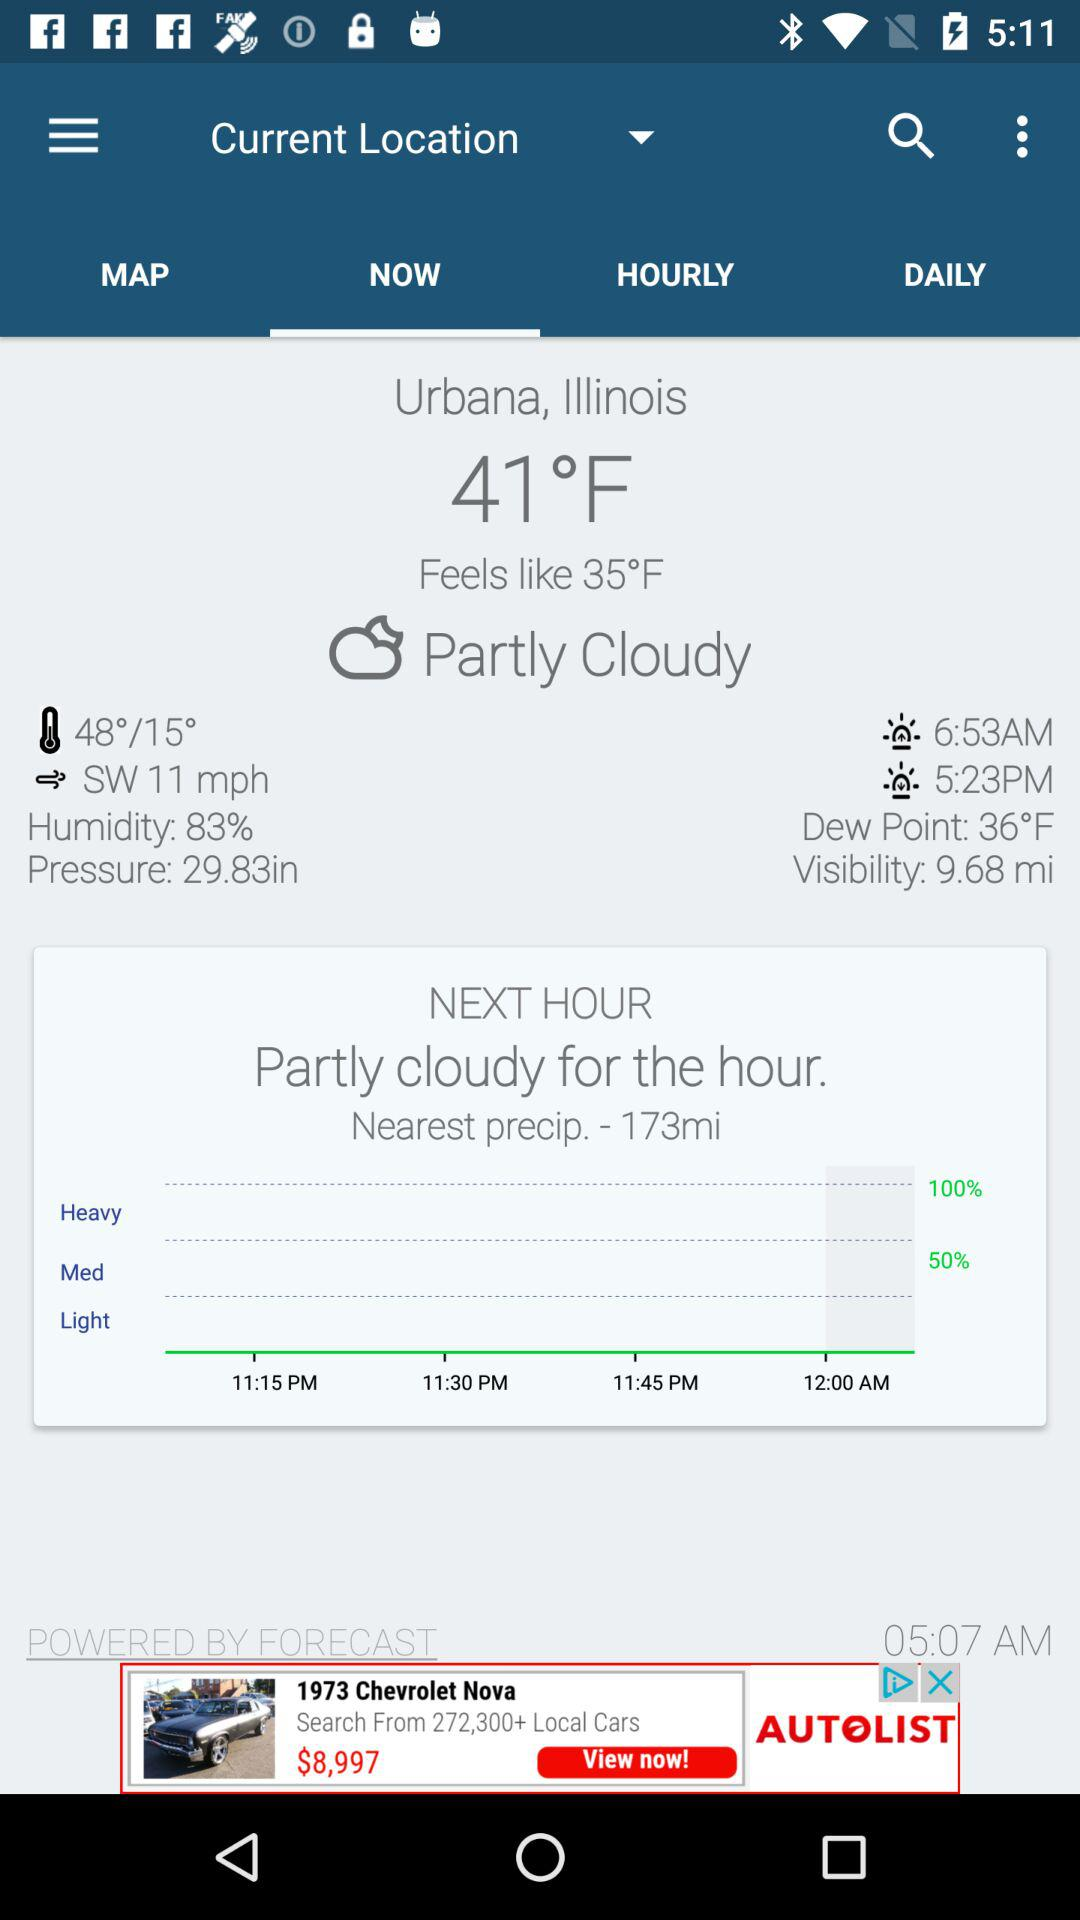What is the wind speed in miles per hour?
Answer the question using a single word or phrase. 11 mph 